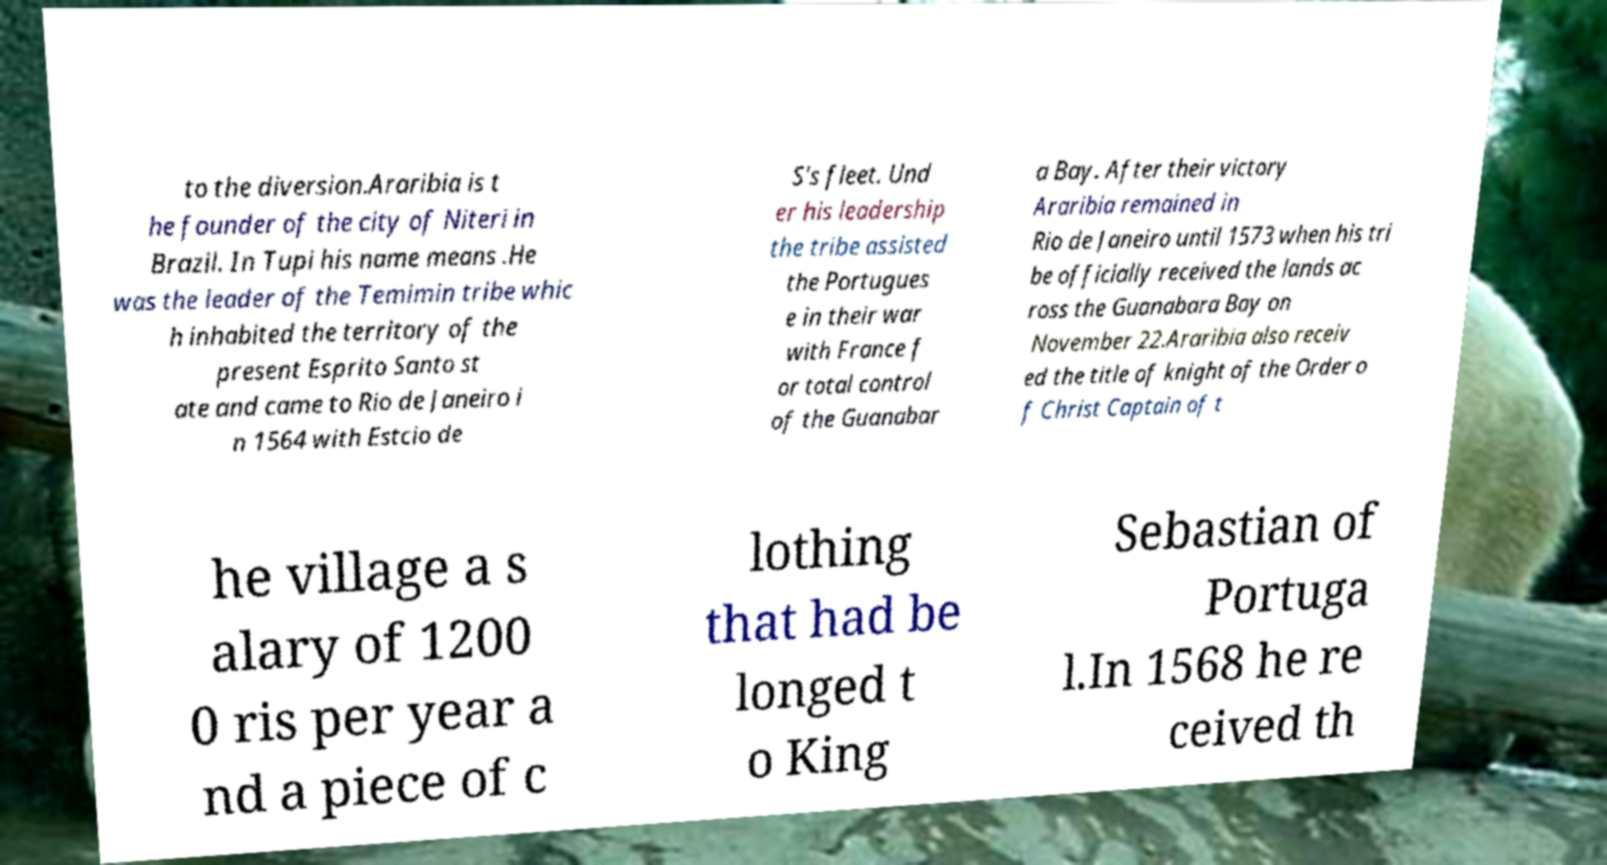Could you assist in decoding the text presented in this image and type it out clearly? to the diversion.Araribia is t he founder of the city of Niteri in Brazil. In Tupi his name means .He was the leader of the Temimin tribe whic h inhabited the territory of the present Esprito Santo st ate and came to Rio de Janeiro i n 1564 with Estcio de S's fleet. Und er his leadership the tribe assisted the Portugues e in their war with France f or total control of the Guanabar a Bay. After their victory Araribia remained in Rio de Janeiro until 1573 when his tri be officially received the lands ac ross the Guanabara Bay on November 22.Araribia also receiv ed the title of knight of the Order o f Christ Captain of t he village a s alary of 1200 0 ris per year a nd a piece of c lothing that had be longed t o King Sebastian of Portuga l.In 1568 he re ceived th 